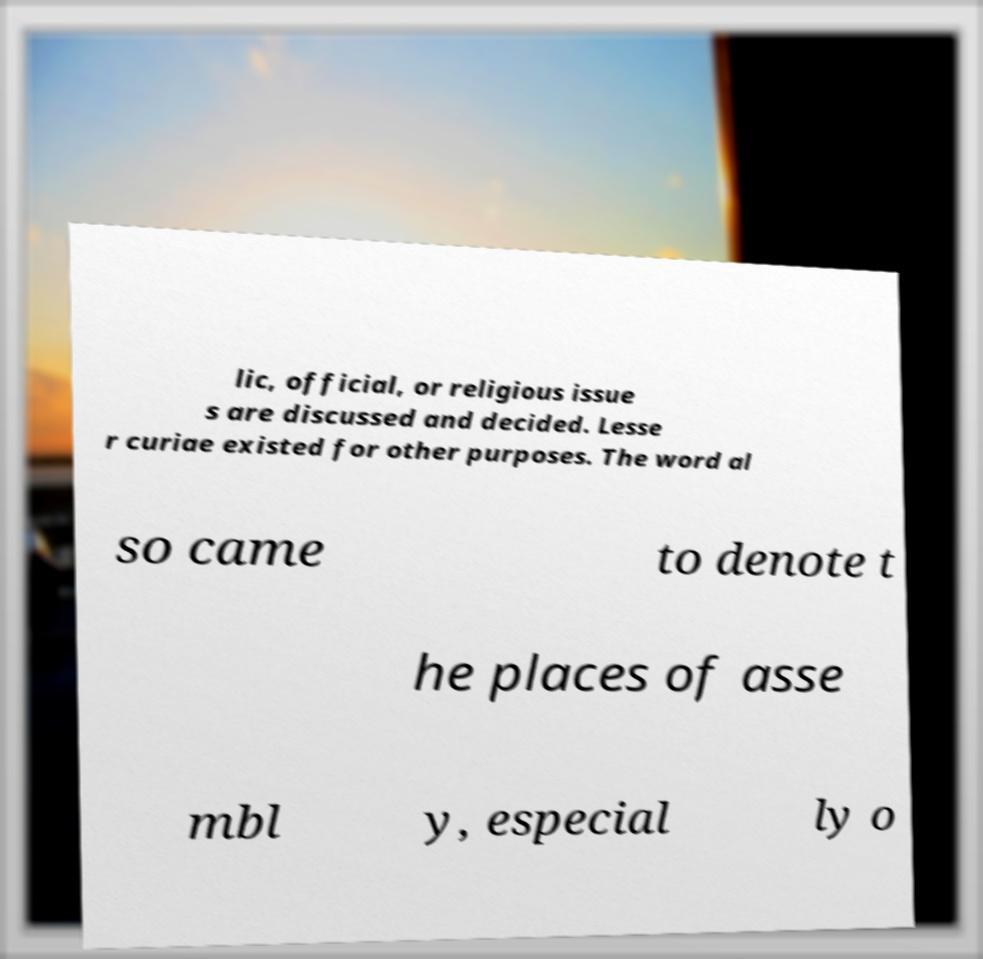I need the written content from this picture converted into text. Can you do that? lic, official, or religious issue s are discussed and decided. Lesse r curiae existed for other purposes. The word al so came to denote t he places of asse mbl y, especial ly o 